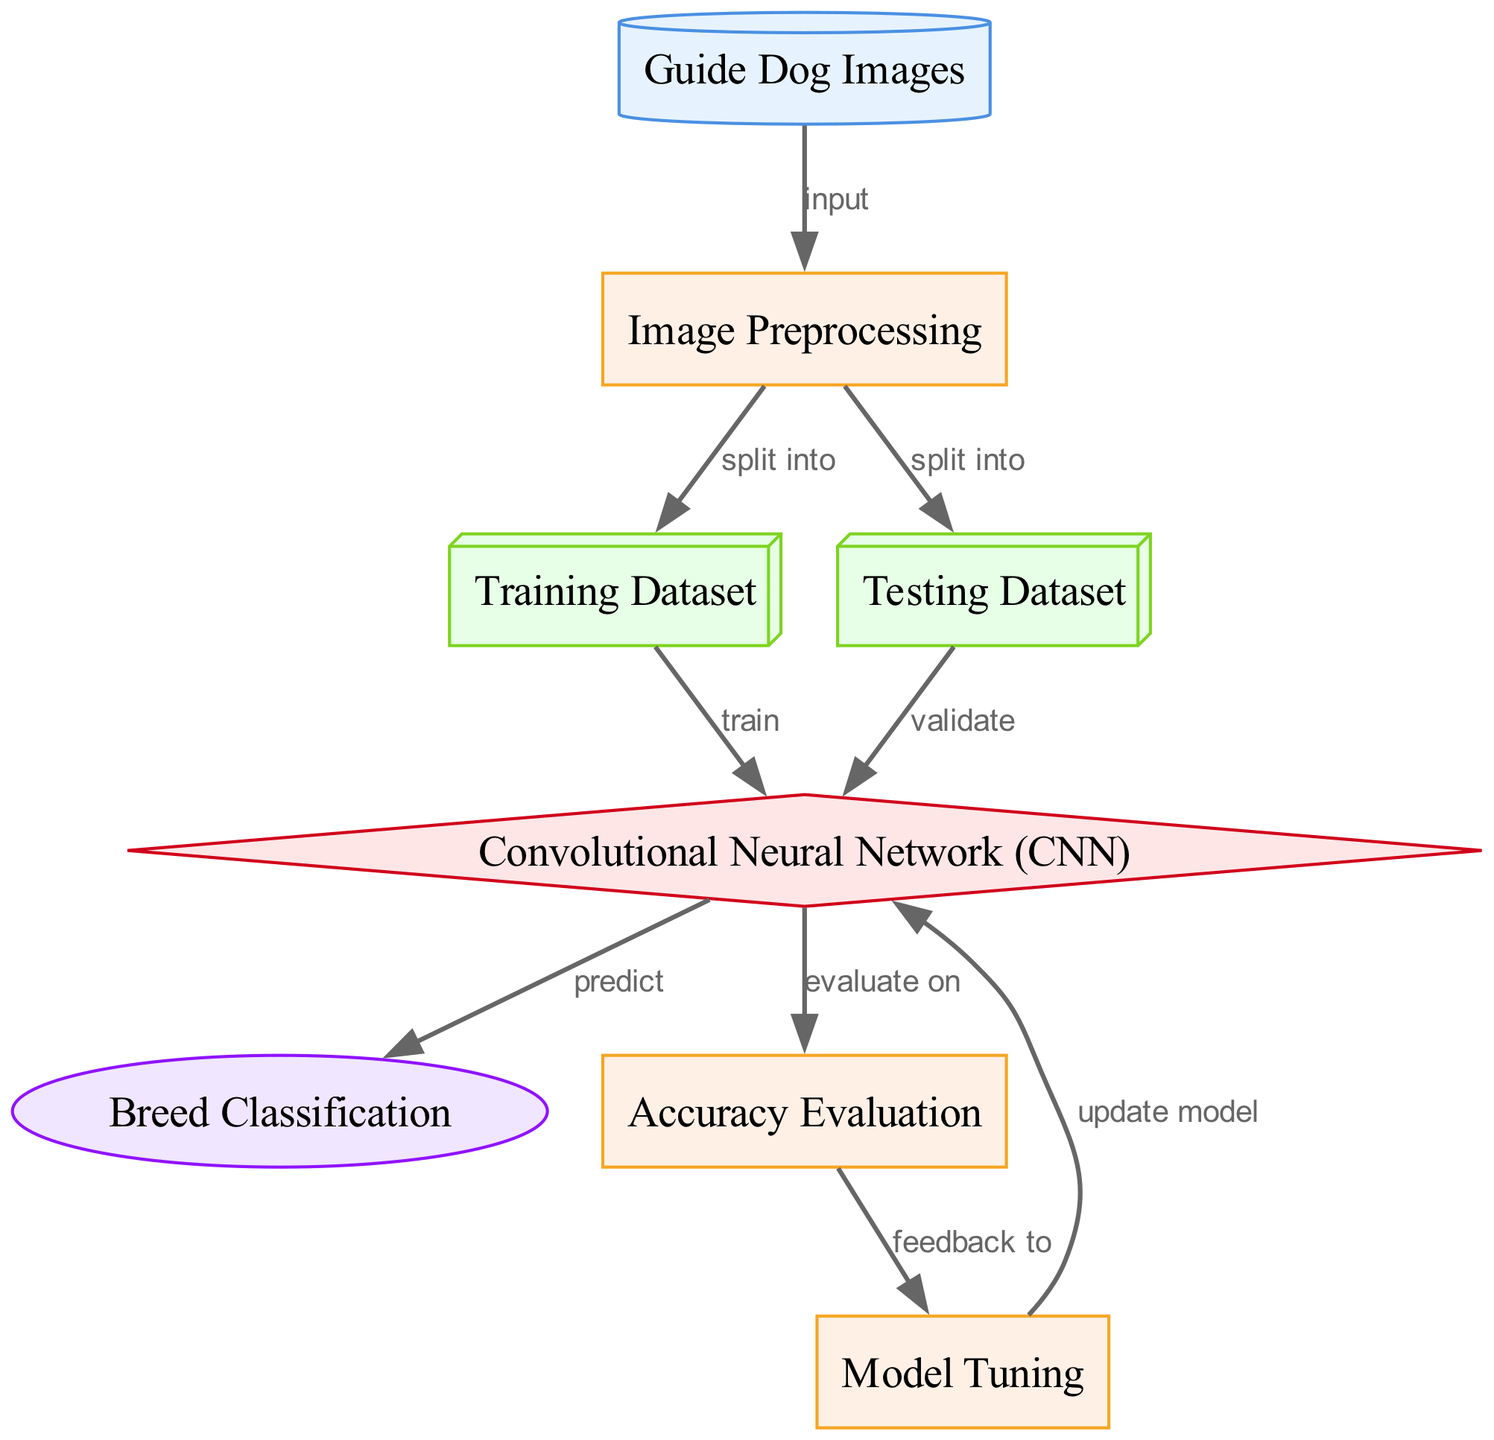What is the starting point of the diagram? The diagram begins with the "Guide Dog Images" node, which serves as the initial data source. Each subsequent process or transformation builds upon this starting point.
Answer: Guide Dog Images How many types of nodes are present in the diagram? The diagram contains five types of nodes: data source, process, data, model, and output. By counting the different categories represented, we can confirm their variety.
Answer: Five Which process follows "Image Preprocessing"? After "Image Preprocessing," the next processes are "Training Dataset" and "Testing Dataset," as the images are split into these two datasets. We determine the subsequent processes by checking the outgoing edges from the "Image Preprocessing" node.
Answer: Training Dataset and Testing Dataset What type of model is used in the diagram? The "Convolutional Neural Network (CNN)" node indicates that it is the specific model utilized in the classification task represented by the diagram. It is identified by the node labeled as a model type.
Answer: Convolutional Neural Network How does the output "Breed Classification" relate to "Convolutional Neural Network"? The output "Breed Classification" is generated from the "Convolutional Neural Network" through a direct prediction step as depicted by the edge connecting these two nodes. The diagram illustrates this relationship, indicating a flow from the model to the output classification.
Answer: Predict What feedback mechanism is present in the model tuning process? After "Accuracy Evaluation," feedback is sent to "Model Tuning," indicating that evaluation results may be used to adjust the model for improved performance. This flow is demonstrated in the diagram through the connecting edge, indicating how output from one process informs another.
Answer: Feedback to Model Tuning How many edges connect to the "Convolutional Neural Network"? The "Convolutional Neural Network" node has three incoming edges, indicating it has multiple processes feeding into it: one from the training dataset and another from the testing dataset, along with the evaluation edge from the accuracy check. Counting these edges gives us insight into how the model takes in data.
Answer: Three What does the "Accuracy Evaluation" process evaluate? The "Accuracy Evaluation" process evaluates the performance of the "Convolutional Neural Network" by comparing its predictions against the results in the testing dataset, which is indicated by the edge leading from the CNN to the evaluation process in the diagram.
Answer: The performance of the Convolutional Neural Network Which datasets are created from the "Image Preprocessing"? "Training Dataset" and "Testing Dataset" are both created from the "Image Preprocessing," as shown by the outgoing edges from the image preprocessing node that indicate the splitting of data.
Answer: Training Dataset and Testing Dataset 